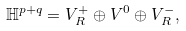Convert formula to latex. <formula><loc_0><loc_0><loc_500><loc_500>\mathbb { H } ^ { p + q } = V _ { R } ^ { + } \oplus V ^ { 0 } \oplus V _ { R } ^ { - } ,</formula> 